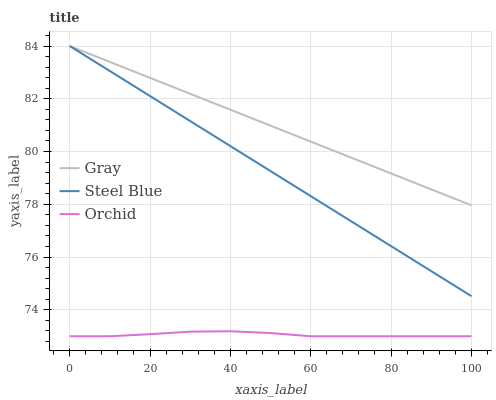Does Orchid have the minimum area under the curve?
Answer yes or no. Yes. Does Gray have the maximum area under the curve?
Answer yes or no. Yes. Does Steel Blue have the minimum area under the curve?
Answer yes or no. No. Does Steel Blue have the maximum area under the curve?
Answer yes or no. No. Is Steel Blue the smoothest?
Answer yes or no. Yes. Is Orchid the roughest?
Answer yes or no. Yes. Is Orchid the smoothest?
Answer yes or no. No. Is Steel Blue the roughest?
Answer yes or no. No. Does Orchid have the lowest value?
Answer yes or no. Yes. Does Steel Blue have the lowest value?
Answer yes or no. No. Does Steel Blue have the highest value?
Answer yes or no. Yes. Does Orchid have the highest value?
Answer yes or no. No. Is Orchid less than Gray?
Answer yes or no. Yes. Is Gray greater than Orchid?
Answer yes or no. Yes. Does Steel Blue intersect Gray?
Answer yes or no. Yes. Is Steel Blue less than Gray?
Answer yes or no. No. Is Steel Blue greater than Gray?
Answer yes or no. No. Does Orchid intersect Gray?
Answer yes or no. No. 